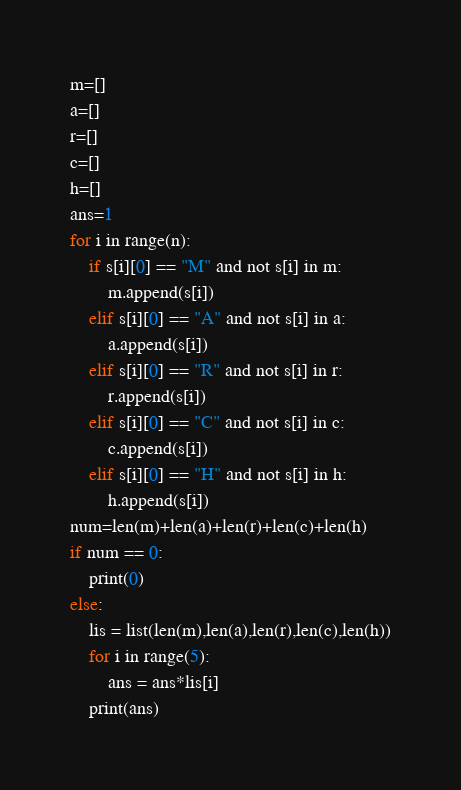Convert code to text. <code><loc_0><loc_0><loc_500><loc_500><_Python_>m=[]
a=[]
r=[]
c=[]
h=[]
ans=1
for i in range(n):
    if s[i][0] == "M" and not s[i] in m:
        m.append(s[i])
    elif s[i][0] == "A" and not s[i] in a:
        a.append(s[i])
    elif s[i][0] == "R" and not s[i] in r:
        r.append(s[i])
    elif s[i][0] == "C" and not s[i] in c:
        c.append(s[i])
    elif s[i][0] == "H" and not s[i] in h:
        h.append(s[i])
num=len(m)+len(a)+len(r)+len(c)+len(h)
if num == 0:
    print(0)
else:
    lis = list(len(m),len(a),len(r),len(c),len(h))
    for i in range(5):
        ans = ans*lis[i] 
    print(ans)</code> 